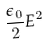<formula> <loc_0><loc_0><loc_500><loc_500>\frac { \epsilon _ { 0 } } { 2 } E ^ { 2 }</formula> 